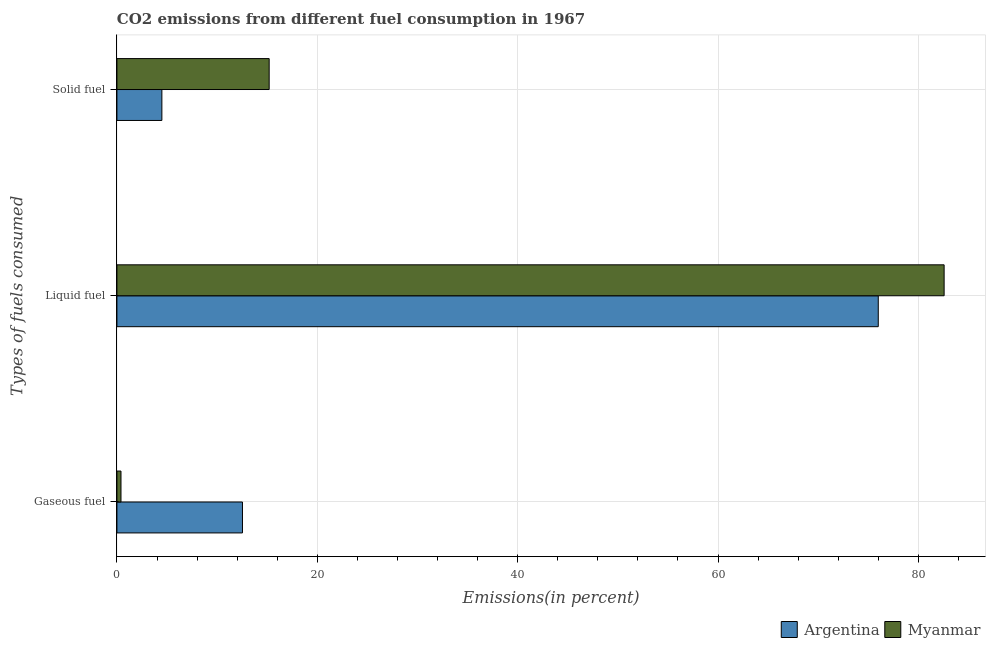How many different coloured bars are there?
Your answer should be compact. 2. How many groups of bars are there?
Provide a short and direct response. 3. Are the number of bars on each tick of the Y-axis equal?
Your answer should be compact. Yes. How many bars are there on the 1st tick from the top?
Offer a very short reply. 2. How many bars are there on the 3rd tick from the bottom?
Keep it short and to the point. 2. What is the label of the 3rd group of bars from the top?
Offer a terse response. Gaseous fuel. What is the percentage of liquid fuel emission in Myanmar?
Your answer should be very brief. 82.57. Across all countries, what is the maximum percentage of solid fuel emission?
Give a very brief answer. 15.2. Across all countries, what is the minimum percentage of liquid fuel emission?
Provide a succinct answer. 76. In which country was the percentage of solid fuel emission maximum?
Offer a terse response. Myanmar. In which country was the percentage of liquid fuel emission minimum?
Keep it short and to the point. Argentina. What is the total percentage of liquid fuel emission in the graph?
Keep it short and to the point. 158.57. What is the difference between the percentage of solid fuel emission in Myanmar and that in Argentina?
Your answer should be compact. 10.71. What is the difference between the percentage of solid fuel emission in Argentina and the percentage of liquid fuel emission in Myanmar?
Make the answer very short. -78.09. What is the average percentage of liquid fuel emission per country?
Your response must be concise. 79.29. What is the difference between the percentage of gaseous fuel emission and percentage of solid fuel emission in Myanmar?
Ensure brevity in your answer.  -14.79. What is the ratio of the percentage of gaseous fuel emission in Argentina to that in Myanmar?
Offer a terse response. 30.92. What is the difference between the highest and the second highest percentage of liquid fuel emission?
Provide a succinct answer. 6.57. What is the difference between the highest and the lowest percentage of gaseous fuel emission?
Give a very brief answer. 12.13. What does the 1st bar from the top in Solid fuel represents?
Offer a very short reply. Myanmar. What does the 1st bar from the bottom in Liquid fuel represents?
Your answer should be very brief. Argentina. How many bars are there?
Your answer should be compact. 6. How many countries are there in the graph?
Offer a terse response. 2. What is the difference between two consecutive major ticks on the X-axis?
Ensure brevity in your answer.  20. Are the values on the major ticks of X-axis written in scientific E-notation?
Offer a terse response. No. Does the graph contain any zero values?
Your answer should be compact. No. Does the graph contain grids?
Provide a short and direct response. Yes. Where does the legend appear in the graph?
Offer a very short reply. Bottom right. How many legend labels are there?
Make the answer very short. 2. What is the title of the graph?
Your answer should be compact. CO2 emissions from different fuel consumption in 1967. Does "Hong Kong" appear as one of the legend labels in the graph?
Offer a terse response. No. What is the label or title of the X-axis?
Your answer should be very brief. Emissions(in percent). What is the label or title of the Y-axis?
Your answer should be very brief. Types of fuels consumed. What is the Emissions(in percent) of Argentina in Gaseous fuel?
Offer a very short reply. 12.53. What is the Emissions(in percent) in Myanmar in Gaseous fuel?
Give a very brief answer. 0.41. What is the Emissions(in percent) in Argentina in Liquid fuel?
Make the answer very short. 76. What is the Emissions(in percent) of Myanmar in Liquid fuel?
Offer a very short reply. 82.57. What is the Emissions(in percent) in Argentina in Solid fuel?
Give a very brief answer. 4.49. What is the Emissions(in percent) in Myanmar in Solid fuel?
Offer a terse response. 15.2. Across all Types of fuels consumed, what is the maximum Emissions(in percent) of Argentina?
Ensure brevity in your answer.  76. Across all Types of fuels consumed, what is the maximum Emissions(in percent) in Myanmar?
Ensure brevity in your answer.  82.57. Across all Types of fuels consumed, what is the minimum Emissions(in percent) of Argentina?
Offer a terse response. 4.49. Across all Types of fuels consumed, what is the minimum Emissions(in percent) in Myanmar?
Your answer should be very brief. 0.41. What is the total Emissions(in percent) of Argentina in the graph?
Provide a succinct answer. 93.02. What is the total Emissions(in percent) of Myanmar in the graph?
Offer a very short reply. 98.18. What is the difference between the Emissions(in percent) in Argentina in Gaseous fuel and that in Liquid fuel?
Offer a very short reply. -63.47. What is the difference between the Emissions(in percent) of Myanmar in Gaseous fuel and that in Liquid fuel?
Provide a short and direct response. -82.17. What is the difference between the Emissions(in percent) in Argentina in Gaseous fuel and that in Solid fuel?
Offer a terse response. 8.05. What is the difference between the Emissions(in percent) of Myanmar in Gaseous fuel and that in Solid fuel?
Offer a terse response. -14.79. What is the difference between the Emissions(in percent) of Argentina in Liquid fuel and that in Solid fuel?
Offer a very short reply. 71.51. What is the difference between the Emissions(in percent) in Myanmar in Liquid fuel and that in Solid fuel?
Make the answer very short. 67.38. What is the difference between the Emissions(in percent) in Argentina in Gaseous fuel and the Emissions(in percent) in Myanmar in Liquid fuel?
Offer a terse response. -70.04. What is the difference between the Emissions(in percent) of Argentina in Gaseous fuel and the Emissions(in percent) of Myanmar in Solid fuel?
Offer a very short reply. -2.67. What is the difference between the Emissions(in percent) of Argentina in Liquid fuel and the Emissions(in percent) of Myanmar in Solid fuel?
Provide a succinct answer. 60.8. What is the average Emissions(in percent) of Argentina per Types of fuels consumed?
Offer a terse response. 31.01. What is the average Emissions(in percent) in Myanmar per Types of fuels consumed?
Offer a very short reply. 32.73. What is the difference between the Emissions(in percent) of Argentina and Emissions(in percent) of Myanmar in Gaseous fuel?
Give a very brief answer. 12.13. What is the difference between the Emissions(in percent) of Argentina and Emissions(in percent) of Myanmar in Liquid fuel?
Your answer should be very brief. -6.57. What is the difference between the Emissions(in percent) in Argentina and Emissions(in percent) in Myanmar in Solid fuel?
Offer a very short reply. -10.71. What is the ratio of the Emissions(in percent) in Argentina in Gaseous fuel to that in Liquid fuel?
Offer a very short reply. 0.16. What is the ratio of the Emissions(in percent) in Myanmar in Gaseous fuel to that in Liquid fuel?
Give a very brief answer. 0. What is the ratio of the Emissions(in percent) in Argentina in Gaseous fuel to that in Solid fuel?
Your response must be concise. 2.79. What is the ratio of the Emissions(in percent) in Myanmar in Gaseous fuel to that in Solid fuel?
Provide a short and direct response. 0.03. What is the ratio of the Emissions(in percent) in Argentina in Liquid fuel to that in Solid fuel?
Offer a terse response. 16.94. What is the ratio of the Emissions(in percent) of Myanmar in Liquid fuel to that in Solid fuel?
Give a very brief answer. 5.43. What is the difference between the highest and the second highest Emissions(in percent) in Argentina?
Make the answer very short. 63.47. What is the difference between the highest and the second highest Emissions(in percent) in Myanmar?
Keep it short and to the point. 67.38. What is the difference between the highest and the lowest Emissions(in percent) in Argentina?
Make the answer very short. 71.51. What is the difference between the highest and the lowest Emissions(in percent) in Myanmar?
Keep it short and to the point. 82.17. 